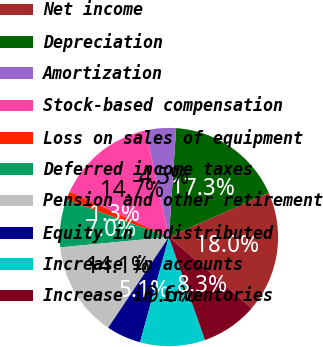Convert chart to OTSL. <chart><loc_0><loc_0><loc_500><loc_500><pie_chart><fcel>Net income<fcel>Depreciation<fcel>Amortization<fcel>Stock-based compensation<fcel>Loss on sales of equipment<fcel>Deferred income taxes<fcel>Pension and other retirement<fcel>Equity in undistributed<fcel>Increase in accounts<fcel>Increase in inventories<nl><fcel>17.95%<fcel>17.31%<fcel>4.49%<fcel>14.74%<fcel>1.28%<fcel>7.05%<fcel>14.1%<fcel>5.13%<fcel>9.62%<fcel>8.33%<nl></chart> 